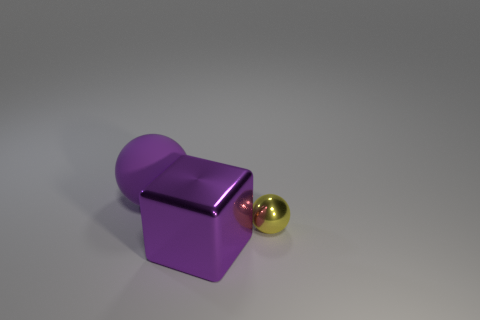There is a shiny object that is to the right of the metal cube; is it the same shape as the purple rubber thing?
Your answer should be very brief. Yes. What shape is the large purple object behind the ball to the right of the big purple cube?
Offer a terse response. Sphere. Is there anything else that is the same shape as the big shiny object?
Ensure brevity in your answer.  No. What color is the tiny metallic thing that is the same shape as the purple matte object?
Your response must be concise. Yellow. There is a cube; does it have the same color as the sphere in front of the purple sphere?
Your answer should be very brief. No. What is the shape of the object that is both in front of the matte thing and behind the large block?
Your answer should be very brief. Sphere. Are there fewer cyan shiny cubes than small yellow objects?
Keep it short and to the point. Yes. Are any big brown rubber cylinders visible?
Your answer should be compact. No. How many other objects are there of the same size as the yellow shiny sphere?
Ensure brevity in your answer.  0. Are the yellow ball and the thing that is left of the big purple metallic object made of the same material?
Provide a succinct answer. No. 